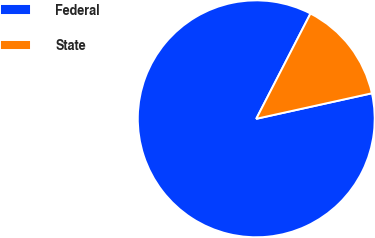Convert chart. <chart><loc_0><loc_0><loc_500><loc_500><pie_chart><fcel>Federal<fcel>State<nl><fcel>86.03%<fcel>13.97%<nl></chart> 